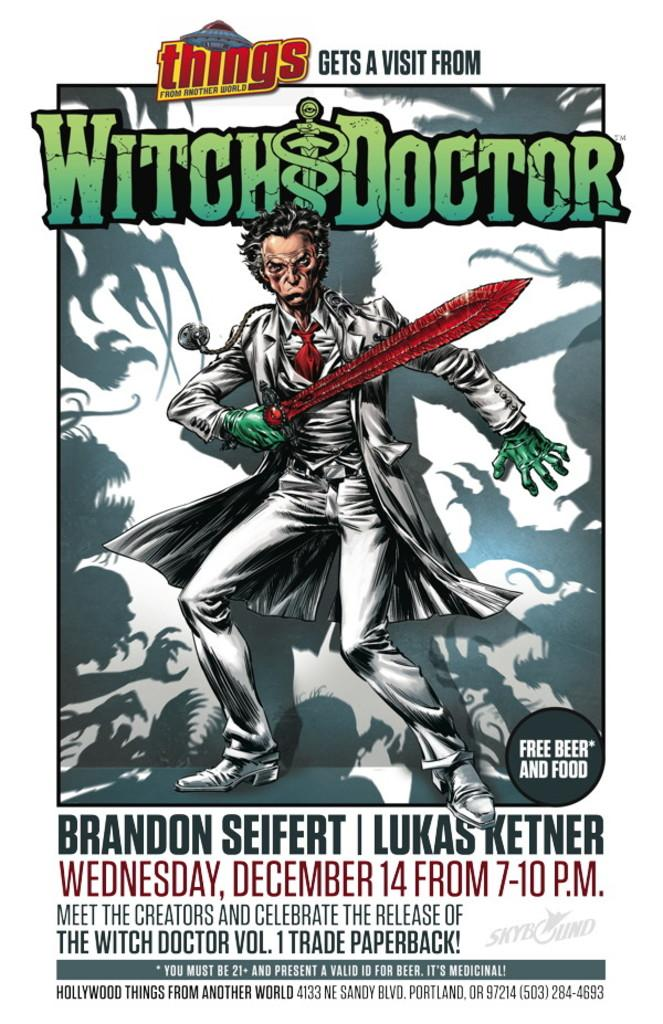<image>
Write a terse but informative summary of the picture. An advertisment for Witch & Doctor on December 14 from 7-10. 